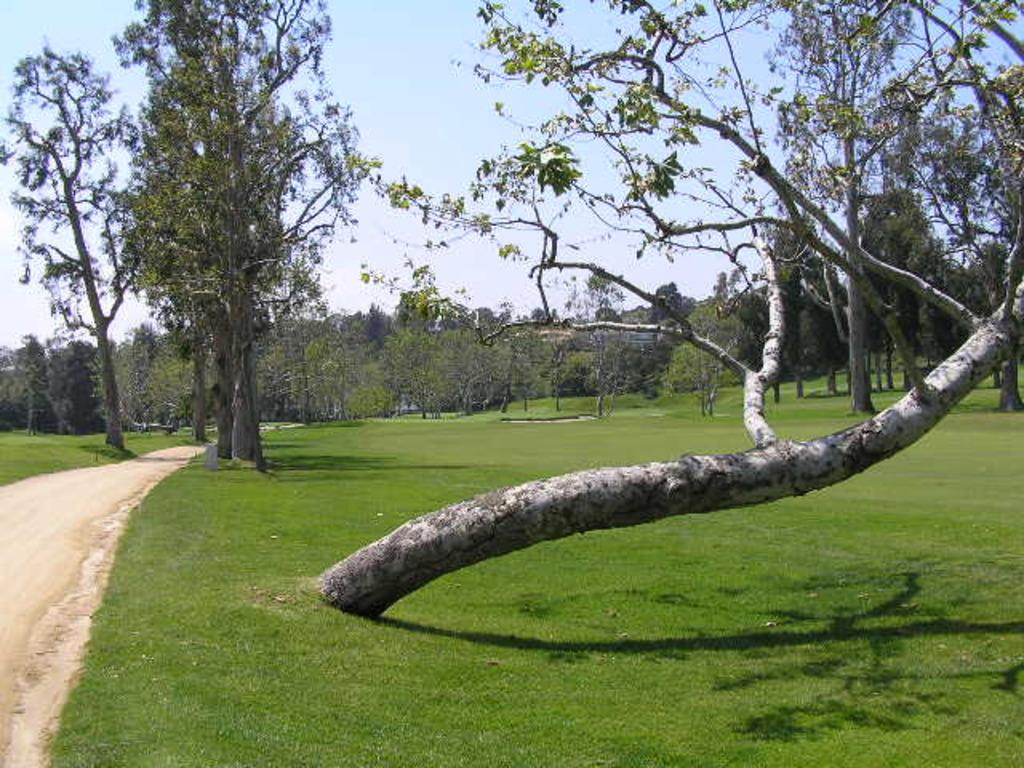What is the main feature of the image? There is a road in the image. What can be seen alongside the road? There are trees in the image. What part of the trees is visible? Tree trunks are visible in the image. What is visible in the sky in the image? There are clouds in the sky in the image. How many servants are present in the image? There are no servants present in the image. What type of adjustment is being made to the drain in the image? There is no drain present in the image. 